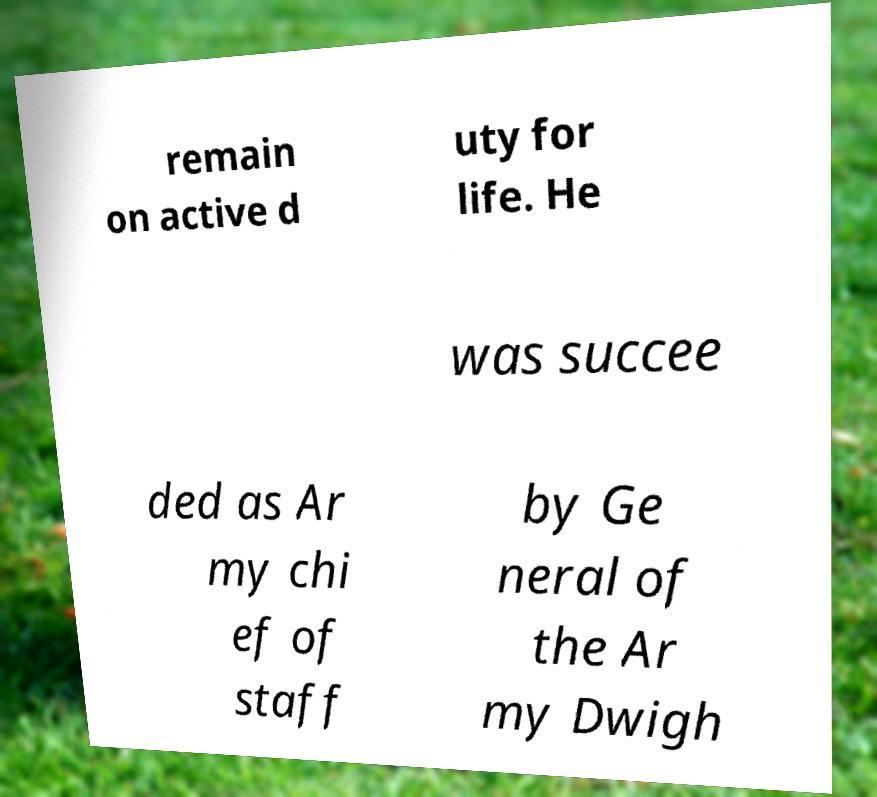I need the written content from this picture converted into text. Can you do that? remain on active d uty for life. He was succee ded as Ar my chi ef of staff by Ge neral of the Ar my Dwigh 